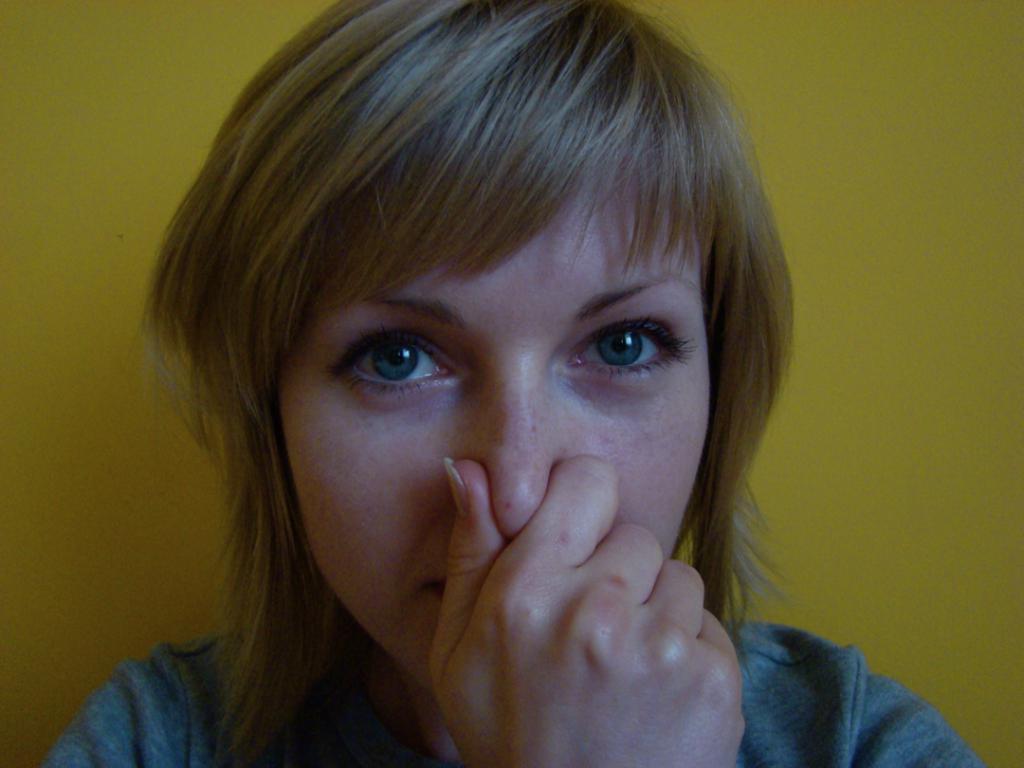In one or two sentences, can you explain what this image depicts? In this image a woman is there, she is closing her nose with her hand. 